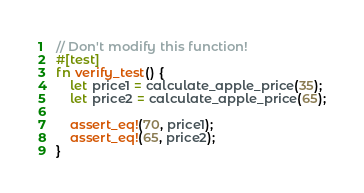<code> <loc_0><loc_0><loc_500><loc_500><_Rust_>
// Don't modify this function!
#[test]
fn verify_test() {
    let price1 = calculate_apple_price(35);
    let price2 = calculate_apple_price(65);

    assert_eq!(70, price1);
    assert_eq!(65, price2);
}
</code> 